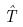Convert formula to latex. <formula><loc_0><loc_0><loc_500><loc_500>\hat { T }</formula> 